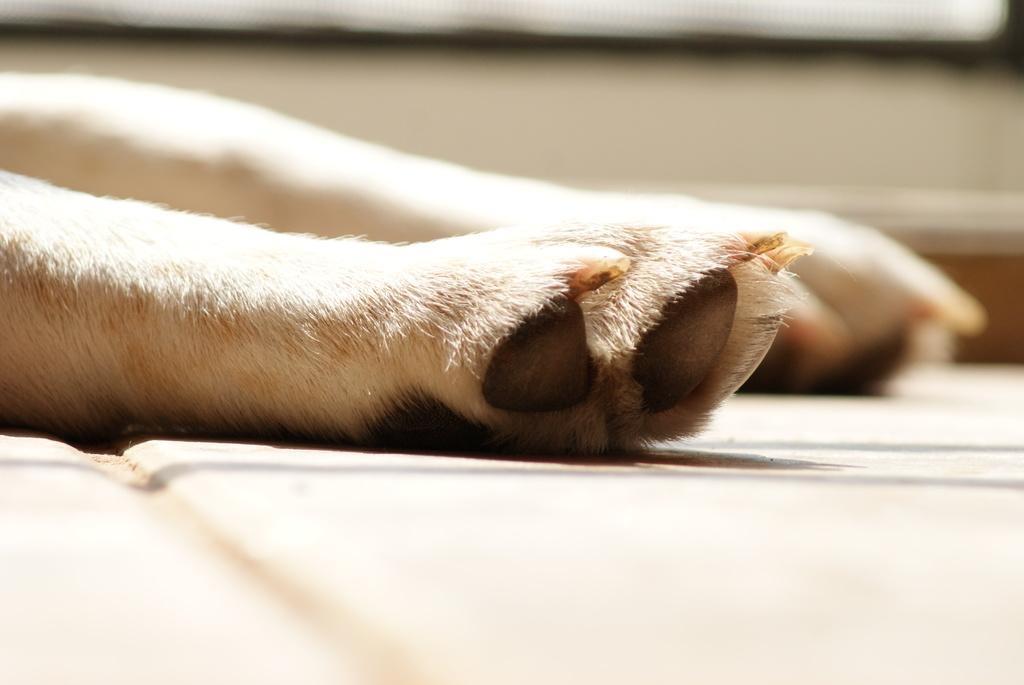What is the surface that the animal's legs are resting on in the image? There is a floor in the image, and the legs of an animal are visible on the floor. What can be inferred about the animal's appearance from the image? The animal has white color hair and legs. What body parts does the animal have that are in contact with the floor? The animal has paws that are in contact with the floor. What feature can be observed on the animal's paws? The animal has nails on its paws. How much debt does the animal owe in the image? There is no mention of debt in the image, as it features an animal with legs, white color hair, paws, and nails. What type of calculator can be seen on the animal's paw in the image? There is no calculator present in the image; it only features an animal with legs, white color hair, paws, and nails. 